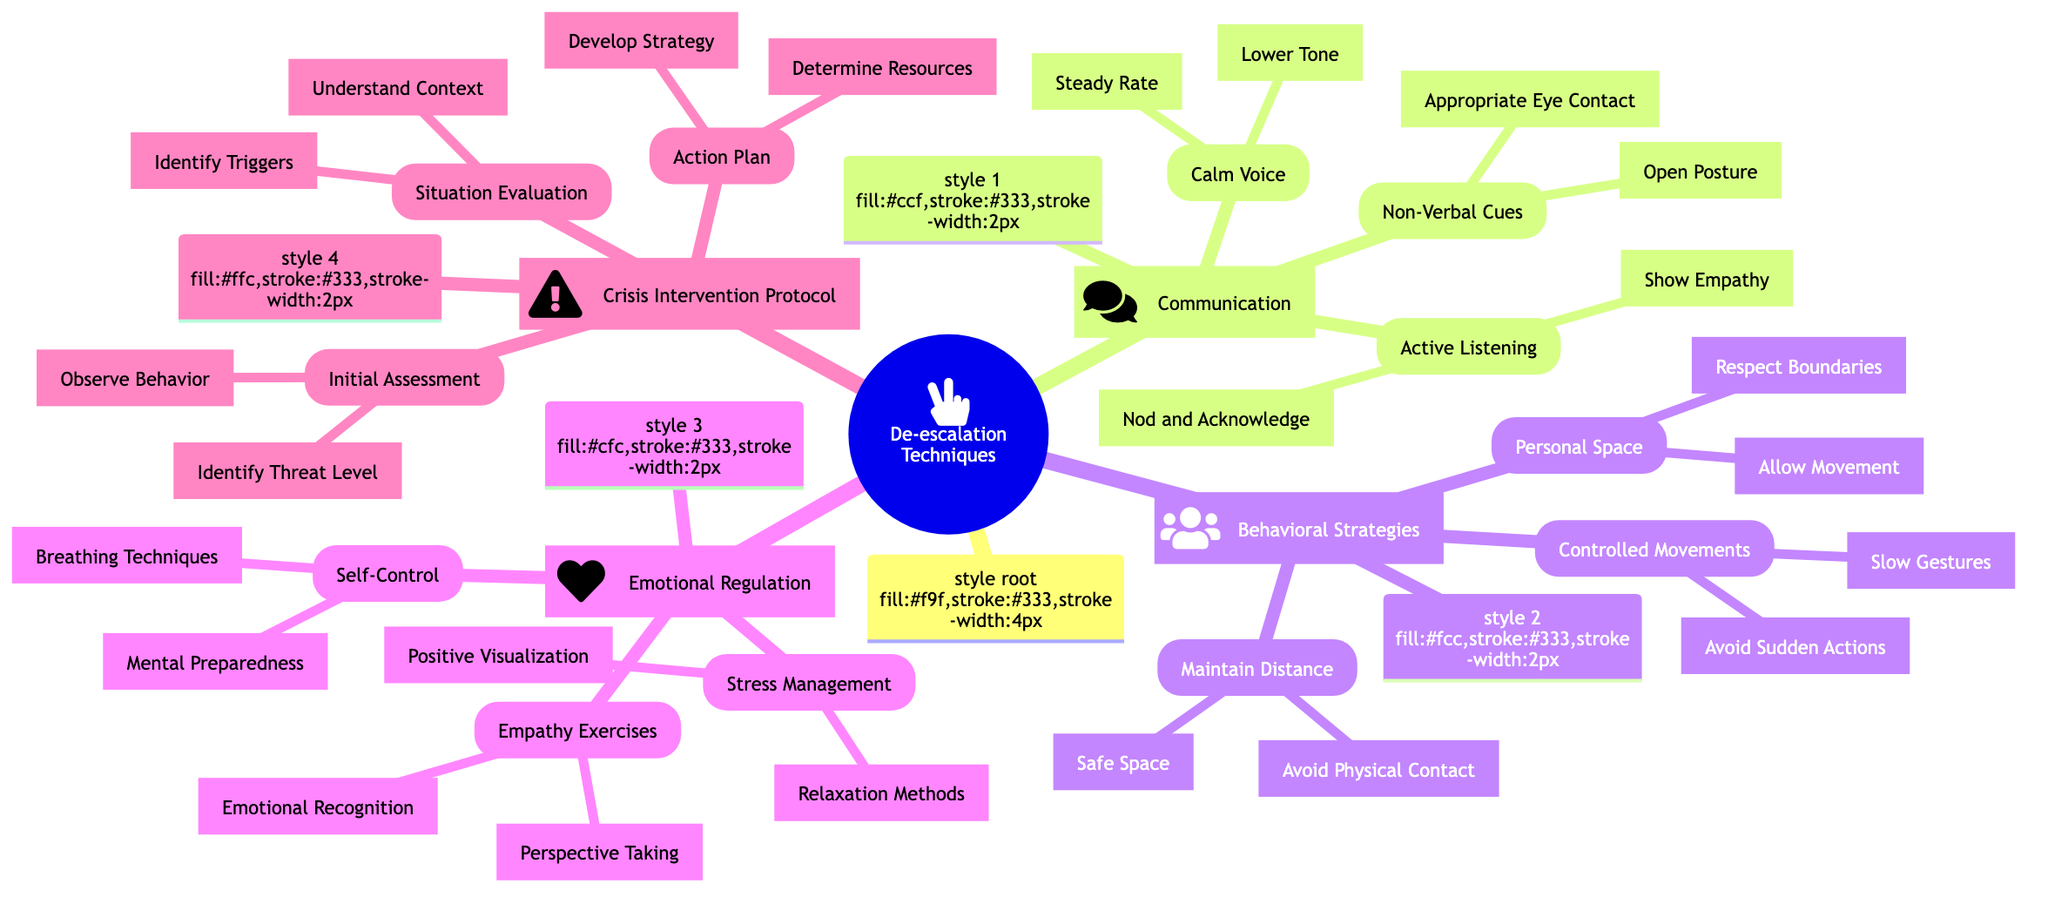What are the three main categories of de-escalation techniques? By looking at the root node of the mind map, we see there are three main branches extending from "De-escalation Techniques": Communication, Behavioral Strategies, and Emotional Regulation.
Answer: Communication, Behavioral Strategies, Emotional Regulation How many types of communication techniques are listed? Under the "Communication" node, there are three subcategories: Active Listening, Calm Voice, and Non-Verbal Cues, totaling three types of communication techniques.
Answer: 3 What is one technique to use during active listening? Within the "Active Listening" category under "Communication," there are two techniques listed: Show Empathy and Nod and Acknowledge. Either of these can answer the question.
Answer: Show Empathy What should be avoided according to the Behavioral Strategies section? One of the key strategies listed under "Maintain Distance" is "Avoid Physical Contact," indicating that avoiding physical contact is advised during de-escalation situations.
Answer: Avoid Physical Contact Which emotional regulation technique involves managing one's thoughts? Under the "Emotional Regulation" category, the technique "Positive Visualization" found in "Stress Management" involves managing one's thoughts to cope with stress effectively.
Answer: Positive Visualization What is the first step in the Crisis Intervention Protocol? In the "Crisis Intervention Protocol," the first subcategory is "Initial Assessment," which includes "Identify Threat Level" as the first action to take.
Answer: Identify Threat Level How many techniques are under Controlled Movements? The node for "Controlled Movements" under "Behavioral Strategies" lists two techniques: Slow Gestures and Avoid Sudden Actions, leading to a total of two techniques.
Answer: 2 What is a critical element of Situation Evaluation? Under the "Situation Evaluation" node, "Identify Triggers" is one of the critical elements necessary to understand the context of the situation properly.
Answer: Identify Triggers What non-verbal cue suggests openness? Among the two listed under "Non-Verbal Cues," "Open Posture" indicates an openness to communication during de-escalation efforts.
Answer: Open Posture 